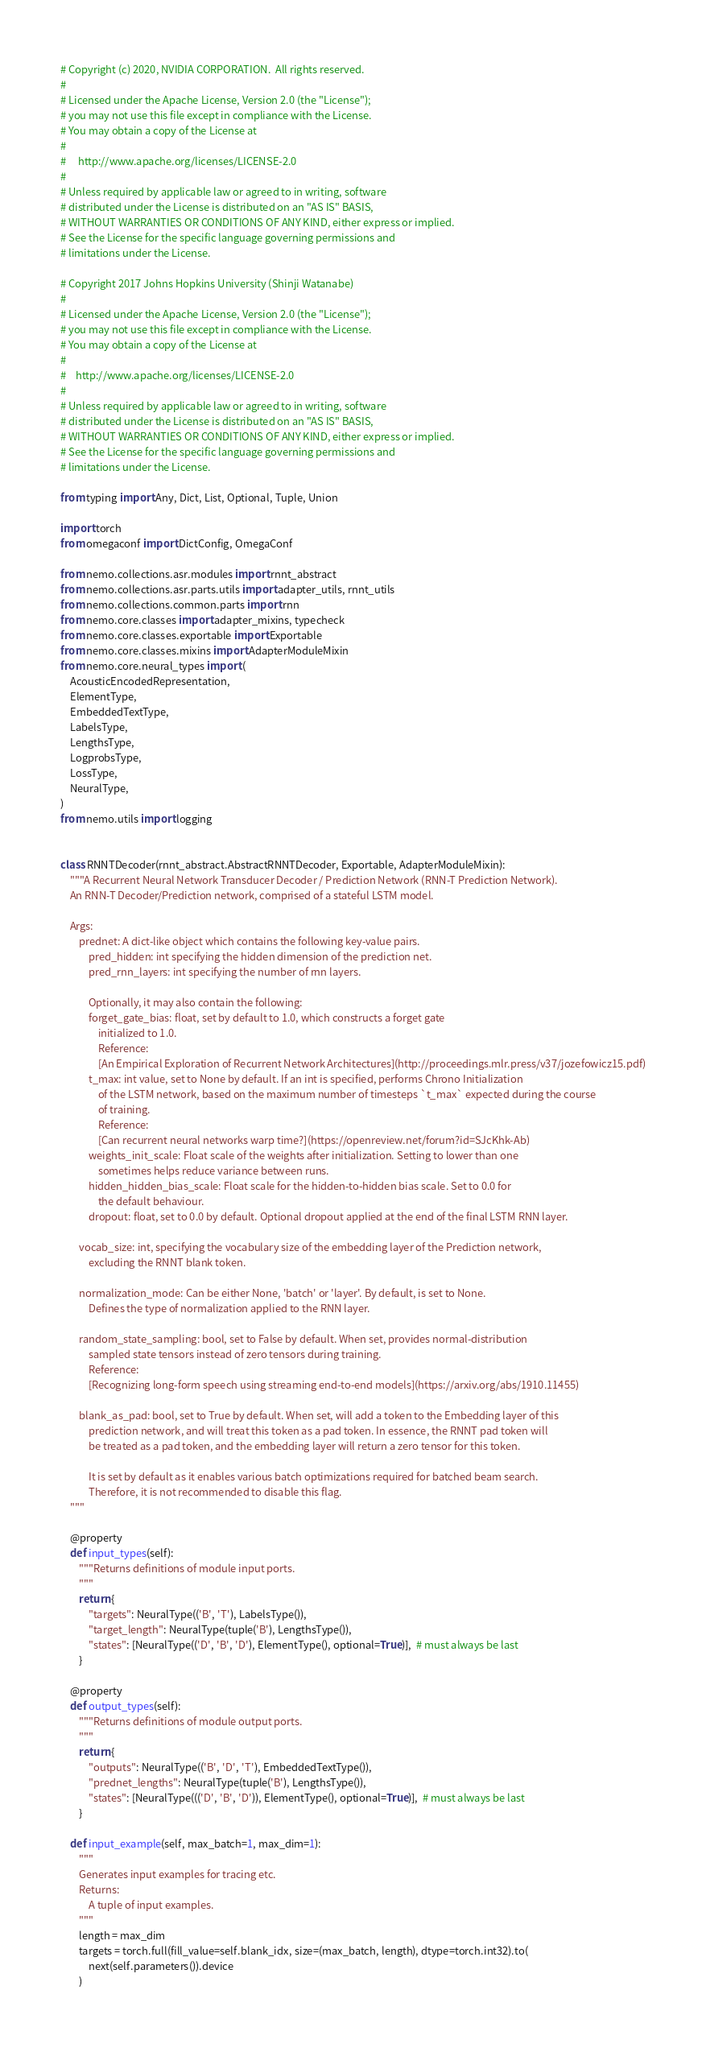<code> <loc_0><loc_0><loc_500><loc_500><_Python_># Copyright (c) 2020, NVIDIA CORPORATION.  All rights reserved.
#
# Licensed under the Apache License, Version 2.0 (the "License");
# you may not use this file except in compliance with the License.
# You may obtain a copy of the License at
#
#     http://www.apache.org/licenses/LICENSE-2.0
#
# Unless required by applicable law or agreed to in writing, software
# distributed under the License is distributed on an "AS IS" BASIS,
# WITHOUT WARRANTIES OR CONDITIONS OF ANY KIND, either express or implied.
# See the License for the specific language governing permissions and
# limitations under the License.

# Copyright 2017 Johns Hopkins University (Shinji Watanabe)
#
# Licensed under the Apache License, Version 2.0 (the "License");
# you may not use this file except in compliance with the License.
# You may obtain a copy of the License at
#
#    http://www.apache.org/licenses/LICENSE-2.0
#
# Unless required by applicable law or agreed to in writing, software
# distributed under the License is distributed on an "AS IS" BASIS,
# WITHOUT WARRANTIES OR CONDITIONS OF ANY KIND, either express or implied.
# See the License for the specific language governing permissions and
# limitations under the License.

from typing import Any, Dict, List, Optional, Tuple, Union

import torch
from omegaconf import DictConfig, OmegaConf

from nemo.collections.asr.modules import rnnt_abstract
from nemo.collections.asr.parts.utils import adapter_utils, rnnt_utils
from nemo.collections.common.parts import rnn
from nemo.core.classes import adapter_mixins, typecheck
from nemo.core.classes.exportable import Exportable
from nemo.core.classes.mixins import AdapterModuleMixin
from nemo.core.neural_types import (
    AcousticEncodedRepresentation,
    ElementType,
    EmbeddedTextType,
    LabelsType,
    LengthsType,
    LogprobsType,
    LossType,
    NeuralType,
)
from nemo.utils import logging


class RNNTDecoder(rnnt_abstract.AbstractRNNTDecoder, Exportable, AdapterModuleMixin):
    """A Recurrent Neural Network Transducer Decoder / Prediction Network (RNN-T Prediction Network).
    An RNN-T Decoder/Prediction network, comprised of a stateful LSTM model.

    Args:
        prednet: A dict-like object which contains the following key-value pairs.
            pred_hidden: int specifying the hidden dimension of the prediction net.
            pred_rnn_layers: int specifying the number of rnn layers.

            Optionally, it may also contain the following:
            forget_gate_bias: float, set by default to 1.0, which constructs a forget gate
                initialized to 1.0.
                Reference:
                [An Empirical Exploration of Recurrent Network Architectures](http://proceedings.mlr.press/v37/jozefowicz15.pdf)
            t_max: int value, set to None by default. If an int is specified, performs Chrono Initialization
                of the LSTM network, based on the maximum number of timesteps `t_max` expected during the course
                of training.
                Reference:
                [Can recurrent neural networks warp time?](https://openreview.net/forum?id=SJcKhk-Ab)
            weights_init_scale: Float scale of the weights after initialization. Setting to lower than one
                sometimes helps reduce variance between runs.
            hidden_hidden_bias_scale: Float scale for the hidden-to-hidden bias scale. Set to 0.0 for
                the default behaviour.
            dropout: float, set to 0.0 by default. Optional dropout applied at the end of the final LSTM RNN layer.

        vocab_size: int, specifying the vocabulary size of the embedding layer of the Prediction network,
            excluding the RNNT blank token.

        normalization_mode: Can be either None, 'batch' or 'layer'. By default, is set to None.
            Defines the type of normalization applied to the RNN layer.

        random_state_sampling: bool, set to False by default. When set, provides normal-distribution
            sampled state tensors instead of zero tensors during training.
            Reference:
            [Recognizing long-form speech using streaming end-to-end models](https://arxiv.org/abs/1910.11455)

        blank_as_pad: bool, set to True by default. When set, will add a token to the Embedding layer of this
            prediction network, and will treat this token as a pad token. In essence, the RNNT pad token will
            be treated as a pad token, and the embedding layer will return a zero tensor for this token.

            It is set by default as it enables various batch optimizations required for batched beam search.
            Therefore, it is not recommended to disable this flag.
    """

    @property
    def input_types(self):
        """Returns definitions of module input ports.
        """
        return {
            "targets": NeuralType(('B', 'T'), LabelsType()),
            "target_length": NeuralType(tuple('B'), LengthsType()),
            "states": [NeuralType(('D', 'B', 'D'), ElementType(), optional=True)],  # must always be last
        }

    @property
    def output_types(self):
        """Returns definitions of module output ports.
        """
        return {
            "outputs": NeuralType(('B', 'D', 'T'), EmbeddedTextType()),
            "prednet_lengths": NeuralType(tuple('B'), LengthsType()),
            "states": [NeuralType((('D', 'B', 'D')), ElementType(), optional=True)],  # must always be last
        }

    def input_example(self, max_batch=1, max_dim=1):
        """
        Generates input examples for tracing etc.
        Returns:
            A tuple of input examples.
        """
        length = max_dim
        targets = torch.full(fill_value=self.blank_idx, size=(max_batch, length), dtype=torch.int32).to(
            next(self.parameters()).device
        )</code> 